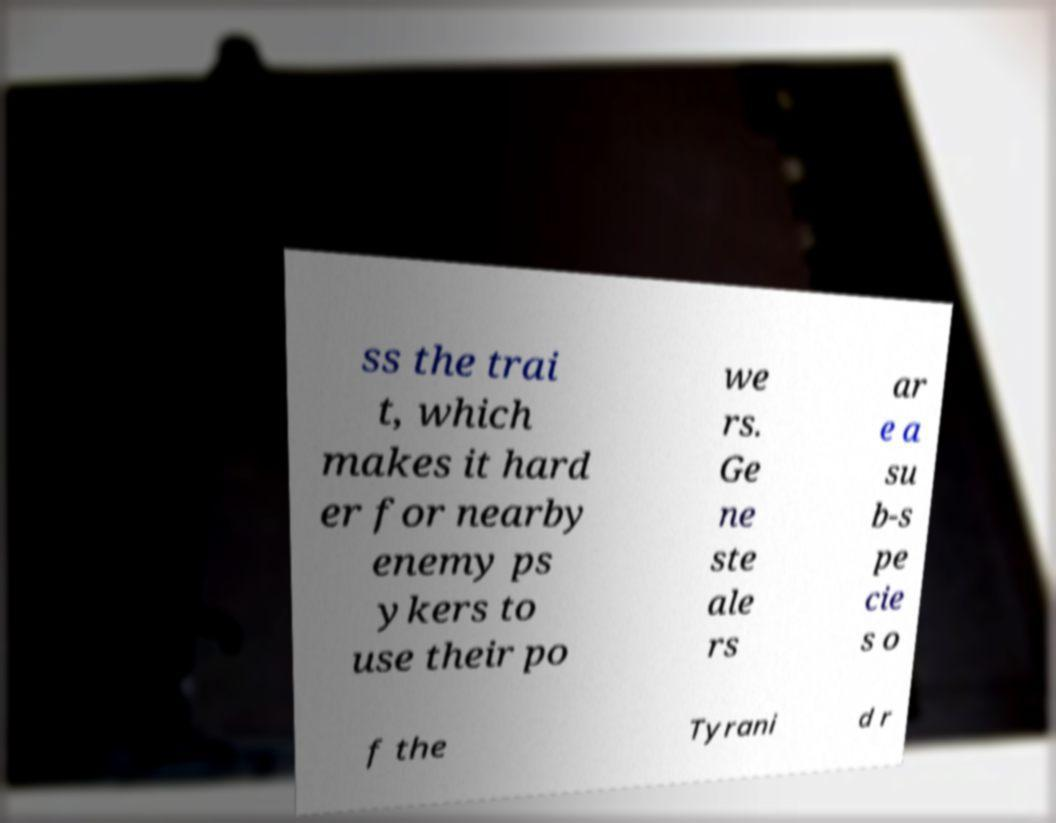Please identify and transcribe the text found in this image. ss the trai t, which makes it hard er for nearby enemy ps ykers to use their po we rs. Ge ne ste ale rs ar e a su b-s pe cie s o f the Tyrani d r 